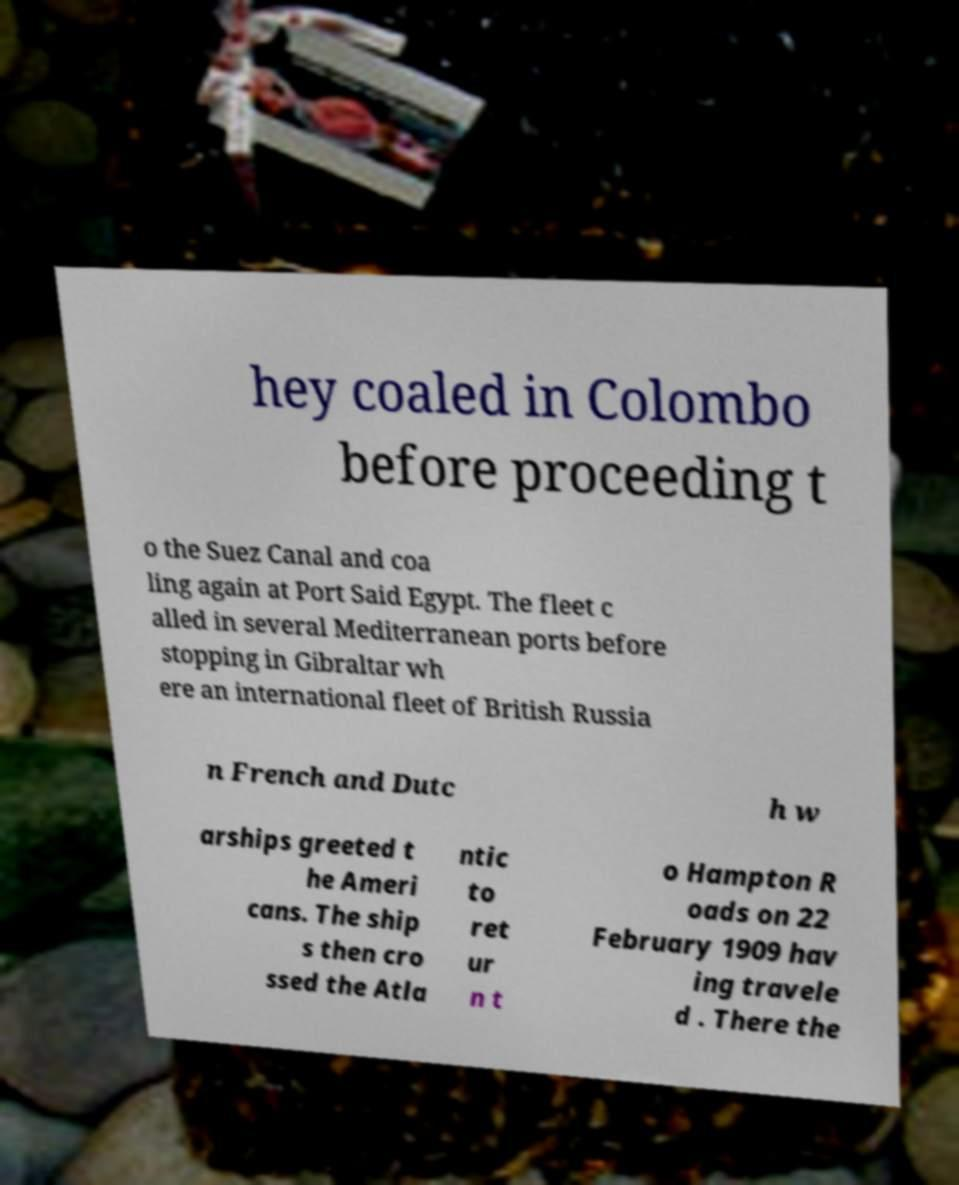Please read and relay the text visible in this image. What does it say? hey coaled in Colombo before proceeding t o the Suez Canal and coa ling again at Port Said Egypt. The fleet c alled in several Mediterranean ports before stopping in Gibraltar wh ere an international fleet of British Russia n French and Dutc h w arships greeted t he Ameri cans. The ship s then cro ssed the Atla ntic to ret ur n t o Hampton R oads on 22 February 1909 hav ing travele d . There the 